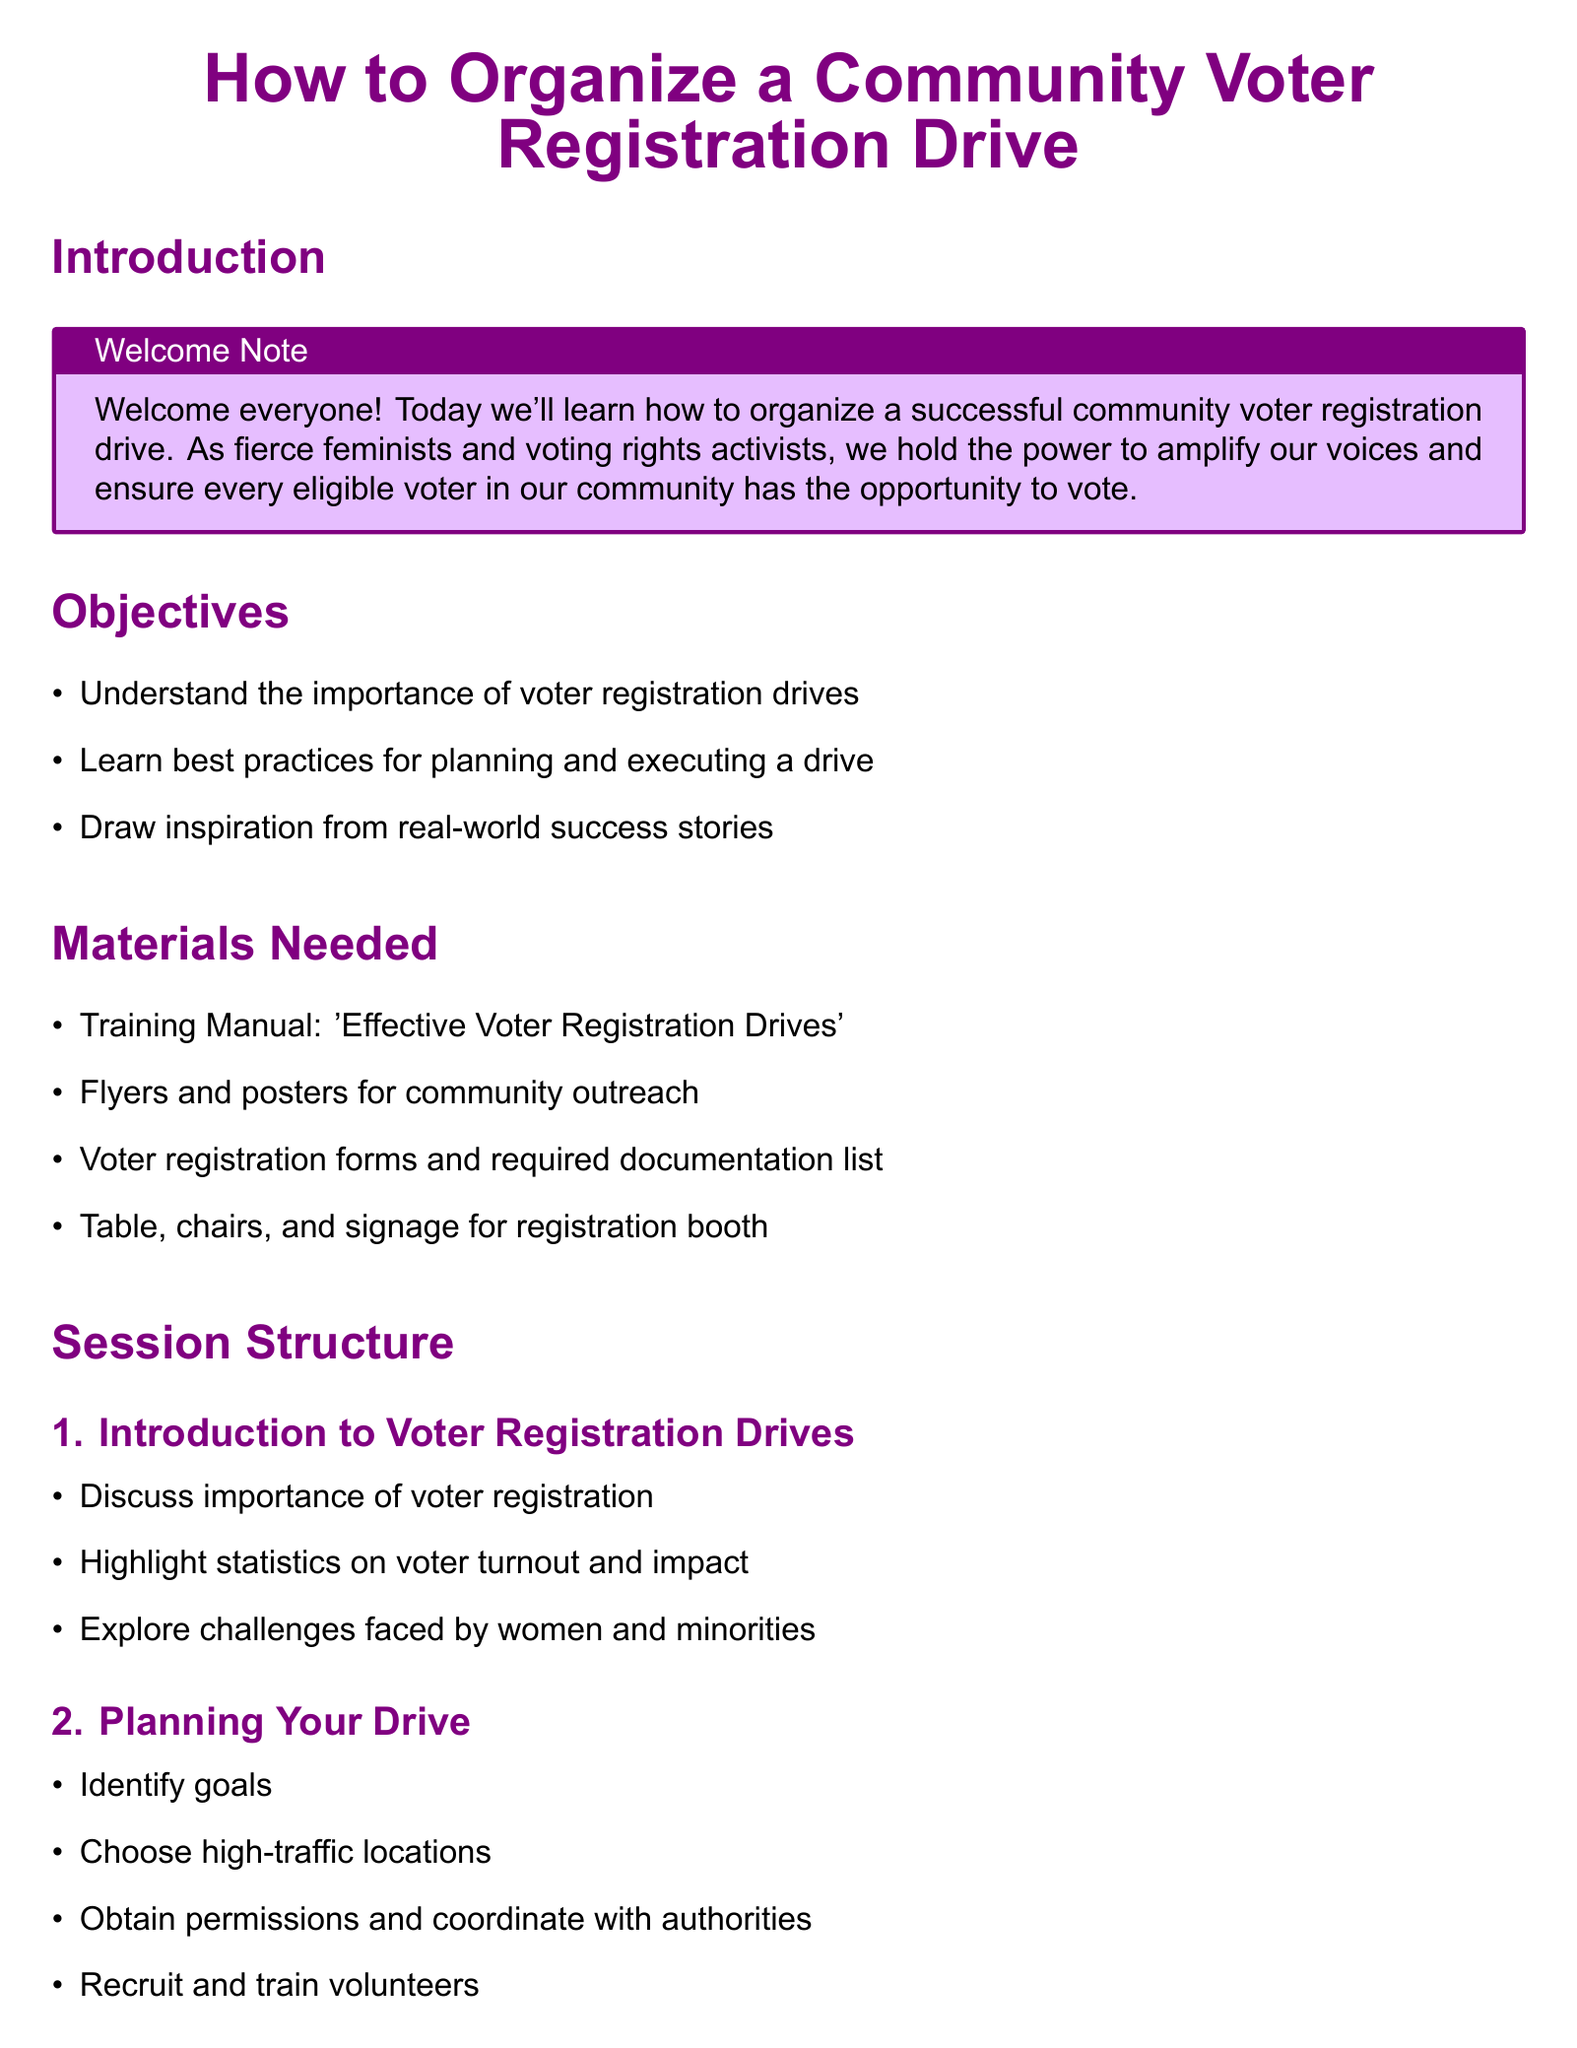what is the title of the lesson plan? The title is presented at the top of the document, which is "How to Organize a Community Voter Registration Drive."
Answer: How to Organize a Community Voter Registration Drive what is the first objective listed? The first objective in the document lists the importance of voter registration drives.
Answer: Understand the importance of voter registration drives how many young voters did Rock the Vote register? The document states that Rock the Vote registered over 12 million young voters.
Answer: 12 million+ what is a key challenge faced by women and minorities? The document indicates that challenges faced by women and minorities are highlighted as part of the discussion on voter registration.
Answer: Challenges in voter registration what materials are required for the drive? The document lists various materials needed for the drive, including training manuals and voter registration forms.
Answer: Training Manual: 'Effective Voter Registration Drives' what should be done to ensure a welcoming environment during the drive? The document advises that engaging in a welcoming manner is essential during the execution of the drive.
Answer: Ensure a welcoming environment what organization registered over 800,000 new voters in Georgia? The document mentions Fair Fight Action as the organization that registered over 800,000 new voters in Georgia.
Answer: Fair Fight Action what is an important part of the planning process? The document mentions identifying goals as a crucial part of the planning process for the voter registration drive.
Answer: Identify goals what type of feedback should be kept after the drive? The document emphasizes the importance of keeping records and following up with registrants.
Answer: Keep records and follow up with registrants 